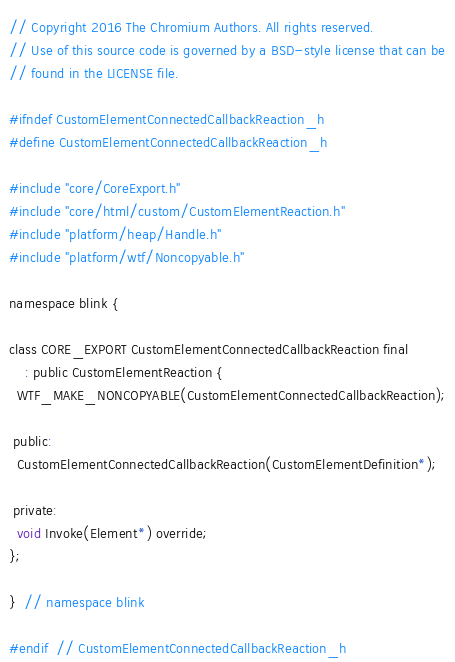Convert code to text. <code><loc_0><loc_0><loc_500><loc_500><_C_>// Copyright 2016 The Chromium Authors. All rights reserved.
// Use of this source code is governed by a BSD-style license that can be
// found in the LICENSE file.

#ifndef CustomElementConnectedCallbackReaction_h
#define CustomElementConnectedCallbackReaction_h

#include "core/CoreExport.h"
#include "core/html/custom/CustomElementReaction.h"
#include "platform/heap/Handle.h"
#include "platform/wtf/Noncopyable.h"

namespace blink {

class CORE_EXPORT CustomElementConnectedCallbackReaction final
    : public CustomElementReaction {
  WTF_MAKE_NONCOPYABLE(CustomElementConnectedCallbackReaction);

 public:
  CustomElementConnectedCallbackReaction(CustomElementDefinition*);

 private:
  void Invoke(Element*) override;
};

}  // namespace blink

#endif  // CustomElementConnectedCallbackReaction_h
</code> 